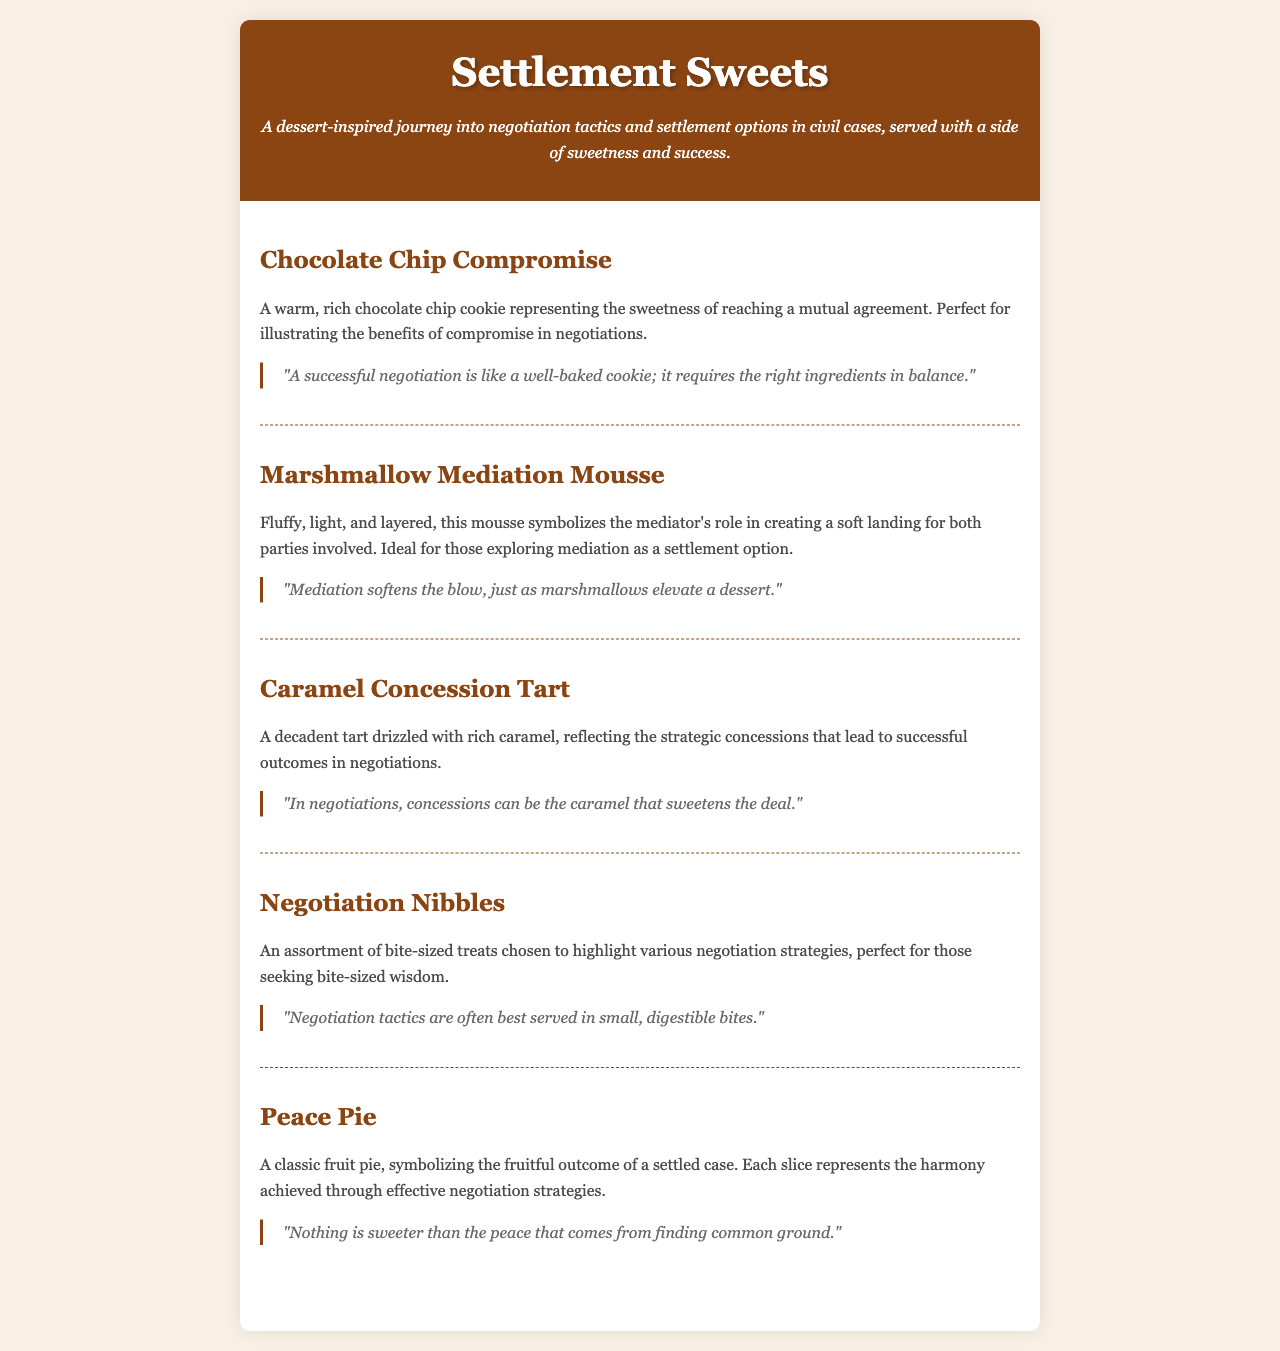What is the title of the menu? The title of the menu is prominently displayed at the top of the document, capturing the essence of the dessert theme.
Answer: Settlement Sweets How many dessert items are listed in the menu? By counting the different sections under "menu-items," you can determine the total number of dessert items provided.
Answer: 5 What does the "Chocolate Chip Compromise" symbolize? The menu describes the "Chocolate Chip Compromise" as representing the sweetness of reaching a mutual agreement in negotiations.
Answer: Mutual agreement Which dessert symbolizes the role of a mediator? The description of the dessert indicates it is associated with the mediator's role in negotiations, providing a soft landing for both parties.
Answer: Marshmallow Mediation Mousse What food item is referred to as "bite-sized treats"? The menu item that highlights various negotiation strategies and is described as bite-sized is named accordingly.
Answer: Negotiation Nibbles What does the quote for the "Peace Pie" highlight? The quote associated with "Peace Pie" illustrates the value of finding common ground in negotiation and its sweet outcome.
Answer: Common ground What type of dessert is the "Caramel Concession Tart"? The menu specifically identifies this dessert as a tart, which is key to understanding its nature and presentation.
Answer: Tart What overarching theme does the menu reflect? The description mentions that the menu explores negotiation tactics represented through sweet treats, tying culinary elements to legal concepts.
Answer: Negotiation tactics 